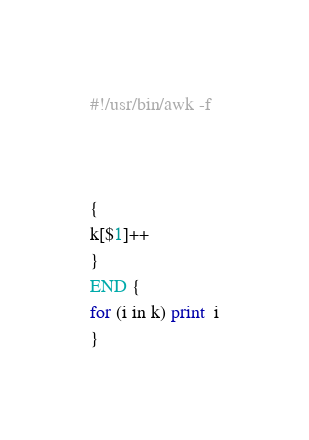<code> <loc_0><loc_0><loc_500><loc_500><_Awk_>#!/usr/bin/awk -f



{
k[$1]++
}
END {
for (i in k) print  i
}
</code> 